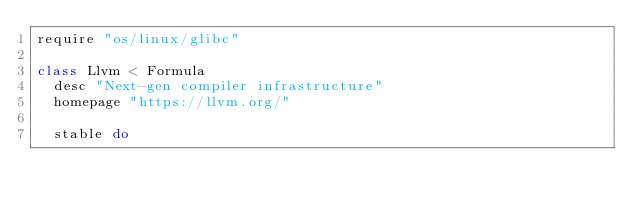<code> <loc_0><loc_0><loc_500><loc_500><_Ruby_>require "os/linux/glibc"

class Llvm < Formula
  desc "Next-gen compiler infrastructure"
  homepage "https://llvm.org/"

  stable do</code> 